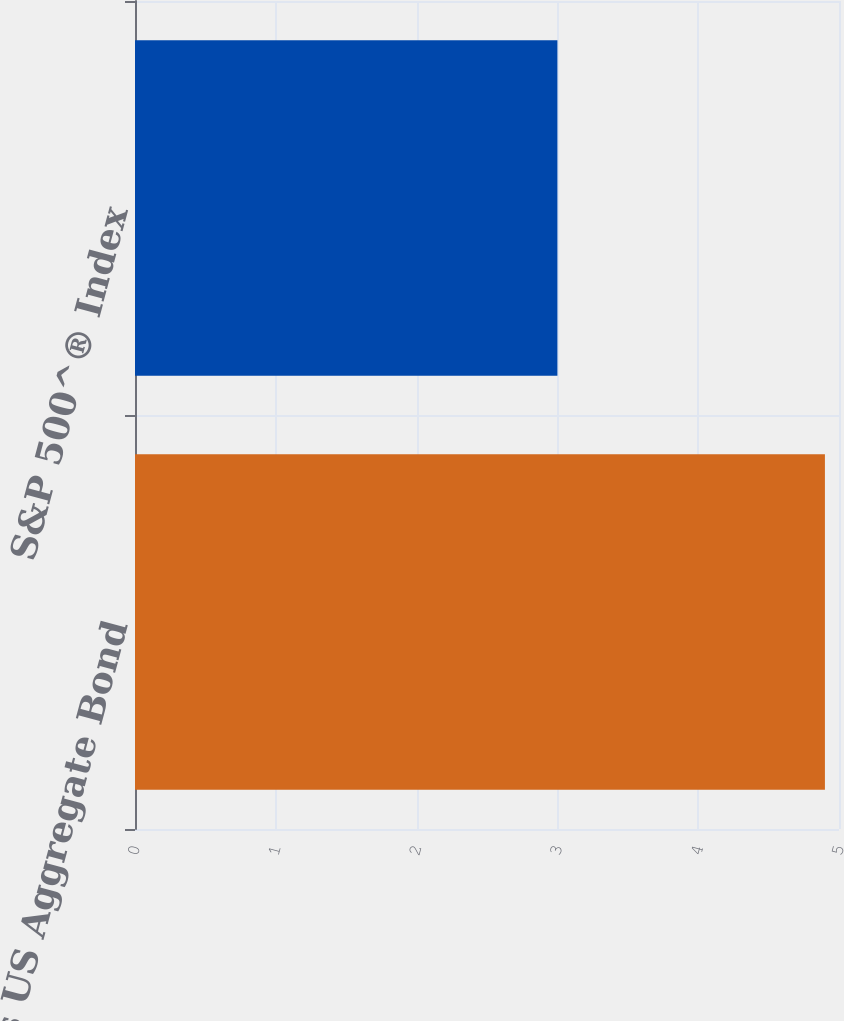Convert chart. <chart><loc_0><loc_0><loc_500><loc_500><bar_chart><fcel>Barclays US Aggregate Bond<fcel>S&P 500^® Index<nl><fcel>4.9<fcel>3<nl></chart> 